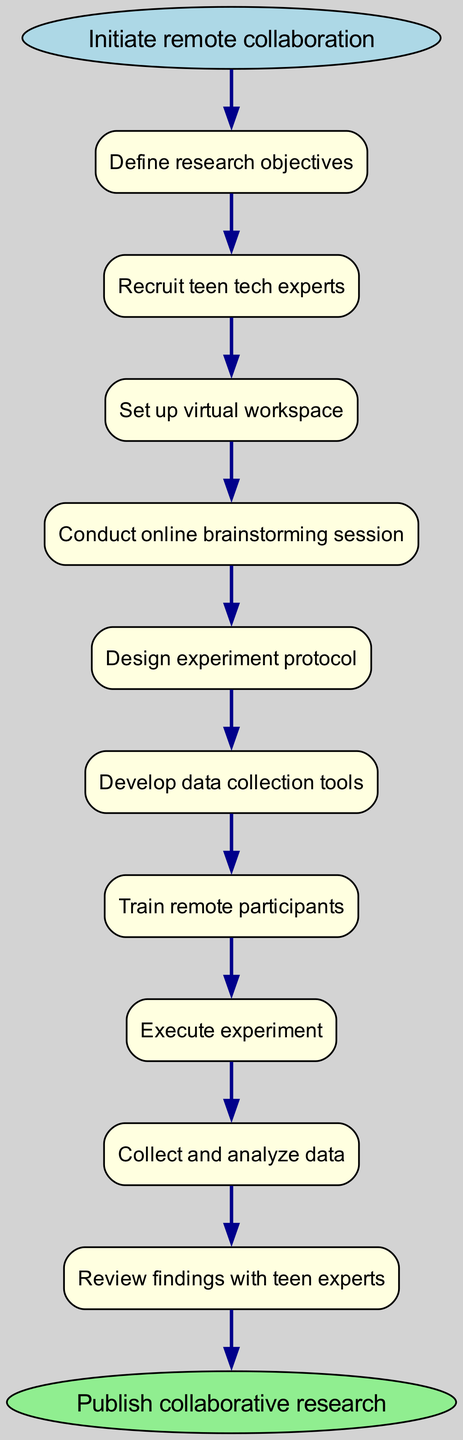What is the first step in the flow chart? The first step is represented by the oval node labeled "Initiate remote collaboration." This is where the collaboration begins according to the diagram.
Answer: Initiate remote collaboration How many total steps are there before the experiment execution? By counting the box nodes leading up to the "Execute experiment" step, we find that there are seven steps in total before reaching that point.
Answer: Seven Which node follows "Review findings with teen experts"? The next node after "Review findings with teen experts" is "Refine research conclusions," indicating that this is the action taken after reviewing findings.
Answer: Refine research conclusions What color is the end node? The end node, which indicates the final state of the flow chart, is colored light green as specified in the diagram structure.
Answer: Light green What action comes immediately before "Collect and analyze data"? Before "Collect and analyze data," the preceding step is "Execute experiment," which signifies that data collection and analysis occur after the experiment has been conducted.
Answer: Execute experiment How does one reach "Develop data collection tools" from "Conduct online brainstorming session"? To reach "Develop data collection tools," you move from "Conduct online brainstorming session" to "Design experiment protocol," then to "Develop data collection tools." Thus, the flow is through two sequential steps.
Answer: Through two steps What is the last step in the process? The final step in this flow chart is denoted by the end node labeled "Publish collaborative research," indicating the conclusion of the overall experiment process.
Answer: Publish collaborative research What is the immediate action following "Train remote participants"? Following "Train remote participants," the immediate action that occurs is "Execute experiment," showing the progression from training to actual execution of the experiment.
Answer: Execute experiment How many edges connect the nodes in total? Each step is connected sequentially to the next with an edge. Since there are ten nodes in total (one start, eight steps, and one end), there will be nine edges connecting all of them together in the flow.
Answer: Nine 